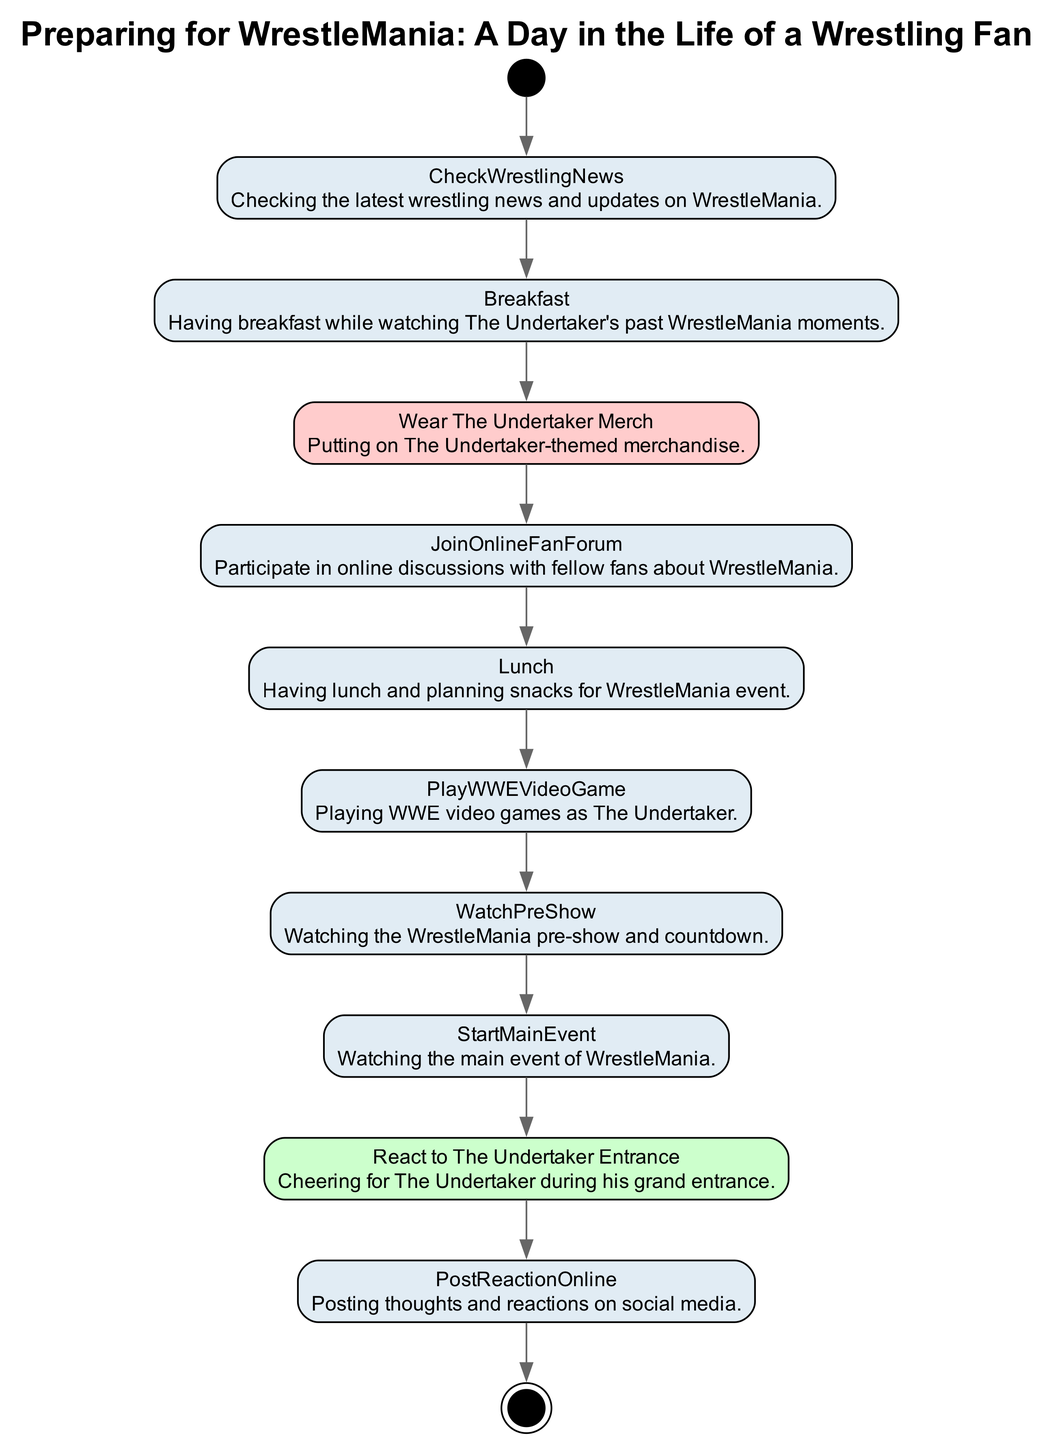What is the initial action in the diagram? The initial action is represented by the "WakeUp" node, which is the first step that a wrestling fan takes in preparing for WrestleMania.
Answer: WakeUp How many actions are in the diagram? By counting the actions listed in the diagram, excluding the initial and final nodes, there are 10 action nodes present.
Answer: 10 What comes after "JoinOnlineFanForum"? The flow depicted in the diagram shows that the action that follows "JoinOnlineFanForum" is "Lunch," indicating that after engaging in discussions, the fan moves on to eat.
Answer: Lunch Which action involves The Undertaker's merchandise? The action that specifically involves The Undertaker's merchandise is "WearTheUndertakerMerch," where the fan puts on themed gear related to The Undertaker.
Answer: WearTheUndertakerMerch What is the final action in the diagram? The final action, depicted as a concluding step in the workflow, is "Sleep," indicating the end of the preparing process after the excitement of WrestleMania.
Answer: Sleep Which action reflects the fan's excitement during the event? The action that captures the fan's excitement is "ReactToTheUndertakerEntrance," where they cheer for The Undertaker as he makes his entrance during the show.
Answer: ReactToTheUndertakerEntrance How does "WatchPreShow" relate to "StartMainEvent"? The diagram shows a sequential flow; "WatchPreShow" precedes "StartMainEvent," meaning the fan watches the pre-show before heading into the main event of WrestleMania.
Answer: StartMainEvent What is the purpose of "PostReactionOnline"? "PostReactionOnline" is for the fan to share their thoughts and interactions about the event on social media after it has concluded, allowing engagement with the wider fan community.
Answer: PostReactionOnline How many edges connect the actions in the diagram? By analyzing the connections or edges indicated in the flow, there are a total of 11 edges connecting the 12 nodes (including initial and final nodes) in the diagram.
Answer: 11 